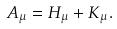<formula> <loc_0><loc_0><loc_500><loc_500>A _ { \mu } = H _ { \mu } + K _ { \mu } .</formula> 